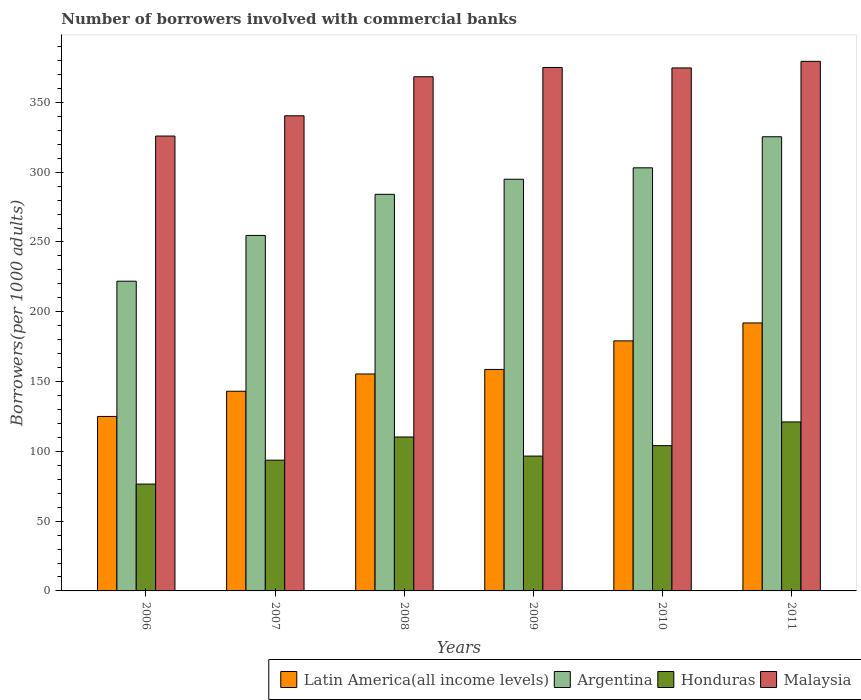How many different coloured bars are there?
Your response must be concise. 4. How many groups of bars are there?
Give a very brief answer. 6. Are the number of bars per tick equal to the number of legend labels?
Your answer should be very brief. Yes. How many bars are there on the 1st tick from the right?
Provide a succinct answer. 4. In how many cases, is the number of bars for a given year not equal to the number of legend labels?
Make the answer very short. 0. What is the number of borrowers involved with commercial banks in Malaysia in 2010?
Your answer should be compact. 374.71. Across all years, what is the maximum number of borrowers involved with commercial banks in Honduras?
Ensure brevity in your answer.  121.07. Across all years, what is the minimum number of borrowers involved with commercial banks in Argentina?
Give a very brief answer. 221.91. In which year was the number of borrowers involved with commercial banks in Latin America(all income levels) maximum?
Keep it short and to the point. 2011. What is the total number of borrowers involved with commercial banks in Honduras in the graph?
Ensure brevity in your answer.  602.3. What is the difference between the number of borrowers involved with commercial banks in Latin America(all income levels) in 2007 and that in 2009?
Make the answer very short. -15.62. What is the difference between the number of borrowers involved with commercial banks in Argentina in 2010 and the number of borrowers involved with commercial banks in Malaysia in 2009?
Provide a succinct answer. -71.88. What is the average number of borrowers involved with commercial banks in Argentina per year?
Ensure brevity in your answer.  280.71. In the year 2006, what is the difference between the number of borrowers involved with commercial banks in Argentina and number of borrowers involved with commercial banks in Latin America(all income levels)?
Your answer should be very brief. 96.91. What is the ratio of the number of borrowers involved with commercial banks in Malaysia in 2007 to that in 2010?
Keep it short and to the point. 0.91. What is the difference between the highest and the second highest number of borrowers involved with commercial banks in Argentina?
Your answer should be very brief. 22.25. What is the difference between the highest and the lowest number of borrowers involved with commercial banks in Honduras?
Your answer should be very brief. 44.52. What does the 4th bar from the left in 2011 represents?
Provide a succinct answer. Malaysia. What does the 2nd bar from the right in 2008 represents?
Provide a short and direct response. Honduras. How many bars are there?
Make the answer very short. 24. What is the difference between two consecutive major ticks on the Y-axis?
Your answer should be very brief. 50. Does the graph contain any zero values?
Your response must be concise. No. Does the graph contain grids?
Your answer should be very brief. No. Where does the legend appear in the graph?
Make the answer very short. Bottom right. How many legend labels are there?
Provide a succinct answer. 4. What is the title of the graph?
Provide a short and direct response. Number of borrowers involved with commercial banks. Does "Euro area" appear as one of the legend labels in the graph?
Give a very brief answer. No. What is the label or title of the Y-axis?
Offer a terse response. Borrowers(per 1000 adults). What is the Borrowers(per 1000 adults) in Latin America(all income levels) in 2006?
Your answer should be very brief. 125.01. What is the Borrowers(per 1000 adults) of Argentina in 2006?
Provide a short and direct response. 221.91. What is the Borrowers(per 1000 adults) of Honduras in 2006?
Your response must be concise. 76.56. What is the Borrowers(per 1000 adults) of Malaysia in 2006?
Offer a very short reply. 325.9. What is the Borrowers(per 1000 adults) in Latin America(all income levels) in 2007?
Keep it short and to the point. 143.06. What is the Borrowers(per 1000 adults) of Argentina in 2007?
Your answer should be compact. 254.69. What is the Borrowers(per 1000 adults) of Honduras in 2007?
Offer a very short reply. 93.68. What is the Borrowers(per 1000 adults) of Malaysia in 2007?
Make the answer very short. 340.42. What is the Borrowers(per 1000 adults) in Latin America(all income levels) in 2008?
Your response must be concise. 155.43. What is the Borrowers(per 1000 adults) of Argentina in 2008?
Provide a succinct answer. 284.14. What is the Borrowers(per 1000 adults) of Honduras in 2008?
Offer a terse response. 110.29. What is the Borrowers(per 1000 adults) of Malaysia in 2008?
Ensure brevity in your answer.  368.39. What is the Borrowers(per 1000 adults) in Latin America(all income levels) in 2009?
Offer a terse response. 158.68. What is the Borrowers(per 1000 adults) in Argentina in 2009?
Ensure brevity in your answer.  294.97. What is the Borrowers(per 1000 adults) in Honduras in 2009?
Offer a very short reply. 96.61. What is the Borrowers(per 1000 adults) of Malaysia in 2009?
Provide a short and direct response. 375.03. What is the Borrowers(per 1000 adults) in Latin America(all income levels) in 2010?
Make the answer very short. 179.15. What is the Borrowers(per 1000 adults) in Argentina in 2010?
Provide a succinct answer. 303.14. What is the Borrowers(per 1000 adults) of Honduras in 2010?
Offer a terse response. 104.09. What is the Borrowers(per 1000 adults) of Malaysia in 2010?
Offer a terse response. 374.71. What is the Borrowers(per 1000 adults) in Latin America(all income levels) in 2011?
Make the answer very short. 191.98. What is the Borrowers(per 1000 adults) in Argentina in 2011?
Your answer should be very brief. 325.39. What is the Borrowers(per 1000 adults) of Honduras in 2011?
Provide a succinct answer. 121.07. What is the Borrowers(per 1000 adults) in Malaysia in 2011?
Your answer should be compact. 379.42. Across all years, what is the maximum Borrowers(per 1000 adults) of Latin America(all income levels)?
Your answer should be compact. 191.98. Across all years, what is the maximum Borrowers(per 1000 adults) in Argentina?
Make the answer very short. 325.39. Across all years, what is the maximum Borrowers(per 1000 adults) in Honduras?
Your answer should be very brief. 121.07. Across all years, what is the maximum Borrowers(per 1000 adults) in Malaysia?
Provide a short and direct response. 379.42. Across all years, what is the minimum Borrowers(per 1000 adults) of Latin America(all income levels)?
Offer a very short reply. 125.01. Across all years, what is the minimum Borrowers(per 1000 adults) of Argentina?
Offer a terse response. 221.91. Across all years, what is the minimum Borrowers(per 1000 adults) in Honduras?
Give a very brief answer. 76.56. Across all years, what is the minimum Borrowers(per 1000 adults) in Malaysia?
Provide a short and direct response. 325.9. What is the total Borrowers(per 1000 adults) of Latin America(all income levels) in the graph?
Offer a very short reply. 953.32. What is the total Borrowers(per 1000 adults) of Argentina in the graph?
Give a very brief answer. 1684.25. What is the total Borrowers(per 1000 adults) in Honduras in the graph?
Provide a short and direct response. 602.3. What is the total Borrowers(per 1000 adults) in Malaysia in the graph?
Your answer should be very brief. 2163.87. What is the difference between the Borrowers(per 1000 adults) in Latin America(all income levels) in 2006 and that in 2007?
Keep it short and to the point. -18.05. What is the difference between the Borrowers(per 1000 adults) of Argentina in 2006 and that in 2007?
Offer a very short reply. -32.78. What is the difference between the Borrowers(per 1000 adults) in Honduras in 2006 and that in 2007?
Your answer should be very brief. -17.13. What is the difference between the Borrowers(per 1000 adults) in Malaysia in 2006 and that in 2007?
Keep it short and to the point. -14.51. What is the difference between the Borrowers(per 1000 adults) in Latin America(all income levels) in 2006 and that in 2008?
Your answer should be very brief. -30.42. What is the difference between the Borrowers(per 1000 adults) in Argentina in 2006 and that in 2008?
Make the answer very short. -62.22. What is the difference between the Borrowers(per 1000 adults) of Honduras in 2006 and that in 2008?
Provide a short and direct response. -33.74. What is the difference between the Borrowers(per 1000 adults) in Malaysia in 2006 and that in 2008?
Provide a succinct answer. -42.49. What is the difference between the Borrowers(per 1000 adults) in Latin America(all income levels) in 2006 and that in 2009?
Provide a succinct answer. -33.68. What is the difference between the Borrowers(per 1000 adults) of Argentina in 2006 and that in 2009?
Offer a very short reply. -73.06. What is the difference between the Borrowers(per 1000 adults) of Honduras in 2006 and that in 2009?
Offer a very short reply. -20.05. What is the difference between the Borrowers(per 1000 adults) of Malaysia in 2006 and that in 2009?
Keep it short and to the point. -49.12. What is the difference between the Borrowers(per 1000 adults) of Latin America(all income levels) in 2006 and that in 2010?
Give a very brief answer. -54.14. What is the difference between the Borrowers(per 1000 adults) in Argentina in 2006 and that in 2010?
Ensure brevity in your answer.  -81.23. What is the difference between the Borrowers(per 1000 adults) in Honduras in 2006 and that in 2010?
Ensure brevity in your answer.  -27.54. What is the difference between the Borrowers(per 1000 adults) in Malaysia in 2006 and that in 2010?
Ensure brevity in your answer.  -48.81. What is the difference between the Borrowers(per 1000 adults) in Latin America(all income levels) in 2006 and that in 2011?
Keep it short and to the point. -66.97. What is the difference between the Borrowers(per 1000 adults) of Argentina in 2006 and that in 2011?
Keep it short and to the point. -103.48. What is the difference between the Borrowers(per 1000 adults) in Honduras in 2006 and that in 2011?
Make the answer very short. -44.52. What is the difference between the Borrowers(per 1000 adults) of Malaysia in 2006 and that in 2011?
Keep it short and to the point. -53.51. What is the difference between the Borrowers(per 1000 adults) in Latin America(all income levels) in 2007 and that in 2008?
Provide a succinct answer. -12.37. What is the difference between the Borrowers(per 1000 adults) in Argentina in 2007 and that in 2008?
Your response must be concise. -29.45. What is the difference between the Borrowers(per 1000 adults) in Honduras in 2007 and that in 2008?
Give a very brief answer. -16.61. What is the difference between the Borrowers(per 1000 adults) of Malaysia in 2007 and that in 2008?
Keep it short and to the point. -27.98. What is the difference between the Borrowers(per 1000 adults) of Latin America(all income levels) in 2007 and that in 2009?
Your answer should be compact. -15.62. What is the difference between the Borrowers(per 1000 adults) of Argentina in 2007 and that in 2009?
Your answer should be very brief. -40.28. What is the difference between the Borrowers(per 1000 adults) of Honduras in 2007 and that in 2009?
Keep it short and to the point. -2.93. What is the difference between the Borrowers(per 1000 adults) of Malaysia in 2007 and that in 2009?
Your response must be concise. -34.61. What is the difference between the Borrowers(per 1000 adults) in Latin America(all income levels) in 2007 and that in 2010?
Your answer should be compact. -36.09. What is the difference between the Borrowers(per 1000 adults) of Argentina in 2007 and that in 2010?
Make the answer very short. -48.45. What is the difference between the Borrowers(per 1000 adults) in Honduras in 2007 and that in 2010?
Your response must be concise. -10.41. What is the difference between the Borrowers(per 1000 adults) in Malaysia in 2007 and that in 2010?
Your answer should be very brief. -34.3. What is the difference between the Borrowers(per 1000 adults) in Latin America(all income levels) in 2007 and that in 2011?
Give a very brief answer. -48.92. What is the difference between the Borrowers(per 1000 adults) of Argentina in 2007 and that in 2011?
Provide a short and direct response. -70.7. What is the difference between the Borrowers(per 1000 adults) in Honduras in 2007 and that in 2011?
Your answer should be compact. -27.39. What is the difference between the Borrowers(per 1000 adults) of Malaysia in 2007 and that in 2011?
Your answer should be very brief. -39. What is the difference between the Borrowers(per 1000 adults) of Latin America(all income levels) in 2008 and that in 2009?
Make the answer very short. -3.25. What is the difference between the Borrowers(per 1000 adults) in Argentina in 2008 and that in 2009?
Keep it short and to the point. -10.83. What is the difference between the Borrowers(per 1000 adults) in Honduras in 2008 and that in 2009?
Offer a very short reply. 13.68. What is the difference between the Borrowers(per 1000 adults) of Malaysia in 2008 and that in 2009?
Provide a succinct answer. -6.64. What is the difference between the Borrowers(per 1000 adults) in Latin America(all income levels) in 2008 and that in 2010?
Make the answer very short. -23.72. What is the difference between the Borrowers(per 1000 adults) in Argentina in 2008 and that in 2010?
Keep it short and to the point. -19.01. What is the difference between the Borrowers(per 1000 adults) of Honduras in 2008 and that in 2010?
Make the answer very short. 6.2. What is the difference between the Borrowers(per 1000 adults) of Malaysia in 2008 and that in 2010?
Offer a terse response. -6.32. What is the difference between the Borrowers(per 1000 adults) in Latin America(all income levels) in 2008 and that in 2011?
Your answer should be compact. -36.55. What is the difference between the Borrowers(per 1000 adults) in Argentina in 2008 and that in 2011?
Provide a short and direct response. -41.25. What is the difference between the Borrowers(per 1000 adults) in Honduras in 2008 and that in 2011?
Keep it short and to the point. -10.78. What is the difference between the Borrowers(per 1000 adults) in Malaysia in 2008 and that in 2011?
Make the answer very short. -11.03. What is the difference between the Borrowers(per 1000 adults) of Latin America(all income levels) in 2009 and that in 2010?
Keep it short and to the point. -20.47. What is the difference between the Borrowers(per 1000 adults) in Argentina in 2009 and that in 2010?
Make the answer very short. -8.17. What is the difference between the Borrowers(per 1000 adults) in Honduras in 2009 and that in 2010?
Offer a terse response. -7.48. What is the difference between the Borrowers(per 1000 adults) of Malaysia in 2009 and that in 2010?
Make the answer very short. 0.32. What is the difference between the Borrowers(per 1000 adults) of Latin America(all income levels) in 2009 and that in 2011?
Your answer should be compact. -33.3. What is the difference between the Borrowers(per 1000 adults) in Argentina in 2009 and that in 2011?
Make the answer very short. -30.42. What is the difference between the Borrowers(per 1000 adults) of Honduras in 2009 and that in 2011?
Your answer should be very brief. -24.46. What is the difference between the Borrowers(per 1000 adults) of Malaysia in 2009 and that in 2011?
Give a very brief answer. -4.39. What is the difference between the Borrowers(per 1000 adults) of Latin America(all income levels) in 2010 and that in 2011?
Your answer should be very brief. -12.83. What is the difference between the Borrowers(per 1000 adults) of Argentina in 2010 and that in 2011?
Your answer should be compact. -22.25. What is the difference between the Borrowers(per 1000 adults) in Honduras in 2010 and that in 2011?
Provide a short and direct response. -16.98. What is the difference between the Borrowers(per 1000 adults) in Malaysia in 2010 and that in 2011?
Offer a terse response. -4.71. What is the difference between the Borrowers(per 1000 adults) in Latin America(all income levels) in 2006 and the Borrowers(per 1000 adults) in Argentina in 2007?
Ensure brevity in your answer.  -129.68. What is the difference between the Borrowers(per 1000 adults) of Latin America(all income levels) in 2006 and the Borrowers(per 1000 adults) of Honduras in 2007?
Your answer should be compact. 31.33. What is the difference between the Borrowers(per 1000 adults) in Latin America(all income levels) in 2006 and the Borrowers(per 1000 adults) in Malaysia in 2007?
Ensure brevity in your answer.  -215.41. What is the difference between the Borrowers(per 1000 adults) of Argentina in 2006 and the Borrowers(per 1000 adults) of Honduras in 2007?
Give a very brief answer. 128.23. What is the difference between the Borrowers(per 1000 adults) of Argentina in 2006 and the Borrowers(per 1000 adults) of Malaysia in 2007?
Keep it short and to the point. -118.5. What is the difference between the Borrowers(per 1000 adults) in Honduras in 2006 and the Borrowers(per 1000 adults) in Malaysia in 2007?
Provide a short and direct response. -263.86. What is the difference between the Borrowers(per 1000 adults) in Latin America(all income levels) in 2006 and the Borrowers(per 1000 adults) in Argentina in 2008?
Keep it short and to the point. -159.13. What is the difference between the Borrowers(per 1000 adults) in Latin America(all income levels) in 2006 and the Borrowers(per 1000 adults) in Honduras in 2008?
Make the answer very short. 14.72. What is the difference between the Borrowers(per 1000 adults) in Latin America(all income levels) in 2006 and the Borrowers(per 1000 adults) in Malaysia in 2008?
Keep it short and to the point. -243.38. What is the difference between the Borrowers(per 1000 adults) of Argentina in 2006 and the Borrowers(per 1000 adults) of Honduras in 2008?
Your answer should be compact. 111.62. What is the difference between the Borrowers(per 1000 adults) in Argentina in 2006 and the Borrowers(per 1000 adults) in Malaysia in 2008?
Offer a terse response. -146.48. What is the difference between the Borrowers(per 1000 adults) of Honduras in 2006 and the Borrowers(per 1000 adults) of Malaysia in 2008?
Ensure brevity in your answer.  -291.84. What is the difference between the Borrowers(per 1000 adults) in Latin America(all income levels) in 2006 and the Borrowers(per 1000 adults) in Argentina in 2009?
Offer a terse response. -169.96. What is the difference between the Borrowers(per 1000 adults) of Latin America(all income levels) in 2006 and the Borrowers(per 1000 adults) of Honduras in 2009?
Keep it short and to the point. 28.4. What is the difference between the Borrowers(per 1000 adults) in Latin America(all income levels) in 2006 and the Borrowers(per 1000 adults) in Malaysia in 2009?
Your answer should be compact. -250.02. What is the difference between the Borrowers(per 1000 adults) in Argentina in 2006 and the Borrowers(per 1000 adults) in Honduras in 2009?
Your answer should be very brief. 125.3. What is the difference between the Borrowers(per 1000 adults) in Argentina in 2006 and the Borrowers(per 1000 adults) in Malaysia in 2009?
Your answer should be very brief. -153.11. What is the difference between the Borrowers(per 1000 adults) in Honduras in 2006 and the Borrowers(per 1000 adults) in Malaysia in 2009?
Provide a succinct answer. -298.47. What is the difference between the Borrowers(per 1000 adults) in Latin America(all income levels) in 2006 and the Borrowers(per 1000 adults) in Argentina in 2010?
Provide a short and direct response. -178.14. What is the difference between the Borrowers(per 1000 adults) in Latin America(all income levels) in 2006 and the Borrowers(per 1000 adults) in Honduras in 2010?
Make the answer very short. 20.92. What is the difference between the Borrowers(per 1000 adults) of Latin America(all income levels) in 2006 and the Borrowers(per 1000 adults) of Malaysia in 2010?
Keep it short and to the point. -249.7. What is the difference between the Borrowers(per 1000 adults) of Argentina in 2006 and the Borrowers(per 1000 adults) of Honduras in 2010?
Your response must be concise. 117.82. What is the difference between the Borrowers(per 1000 adults) of Argentina in 2006 and the Borrowers(per 1000 adults) of Malaysia in 2010?
Your response must be concise. -152.8. What is the difference between the Borrowers(per 1000 adults) in Honduras in 2006 and the Borrowers(per 1000 adults) in Malaysia in 2010?
Provide a short and direct response. -298.16. What is the difference between the Borrowers(per 1000 adults) in Latin America(all income levels) in 2006 and the Borrowers(per 1000 adults) in Argentina in 2011?
Offer a very short reply. -200.38. What is the difference between the Borrowers(per 1000 adults) in Latin America(all income levels) in 2006 and the Borrowers(per 1000 adults) in Honduras in 2011?
Your response must be concise. 3.94. What is the difference between the Borrowers(per 1000 adults) in Latin America(all income levels) in 2006 and the Borrowers(per 1000 adults) in Malaysia in 2011?
Your answer should be compact. -254.41. What is the difference between the Borrowers(per 1000 adults) of Argentina in 2006 and the Borrowers(per 1000 adults) of Honduras in 2011?
Your answer should be compact. 100.84. What is the difference between the Borrowers(per 1000 adults) in Argentina in 2006 and the Borrowers(per 1000 adults) in Malaysia in 2011?
Give a very brief answer. -157.5. What is the difference between the Borrowers(per 1000 adults) of Honduras in 2006 and the Borrowers(per 1000 adults) of Malaysia in 2011?
Offer a very short reply. -302.86. What is the difference between the Borrowers(per 1000 adults) of Latin America(all income levels) in 2007 and the Borrowers(per 1000 adults) of Argentina in 2008?
Offer a terse response. -141.08. What is the difference between the Borrowers(per 1000 adults) of Latin America(all income levels) in 2007 and the Borrowers(per 1000 adults) of Honduras in 2008?
Your response must be concise. 32.77. What is the difference between the Borrowers(per 1000 adults) of Latin America(all income levels) in 2007 and the Borrowers(per 1000 adults) of Malaysia in 2008?
Give a very brief answer. -225.33. What is the difference between the Borrowers(per 1000 adults) of Argentina in 2007 and the Borrowers(per 1000 adults) of Honduras in 2008?
Your response must be concise. 144.4. What is the difference between the Borrowers(per 1000 adults) in Argentina in 2007 and the Borrowers(per 1000 adults) in Malaysia in 2008?
Your answer should be compact. -113.7. What is the difference between the Borrowers(per 1000 adults) in Honduras in 2007 and the Borrowers(per 1000 adults) in Malaysia in 2008?
Offer a terse response. -274.71. What is the difference between the Borrowers(per 1000 adults) of Latin America(all income levels) in 2007 and the Borrowers(per 1000 adults) of Argentina in 2009?
Offer a very short reply. -151.91. What is the difference between the Borrowers(per 1000 adults) of Latin America(all income levels) in 2007 and the Borrowers(per 1000 adults) of Honduras in 2009?
Your response must be concise. 46.45. What is the difference between the Borrowers(per 1000 adults) in Latin America(all income levels) in 2007 and the Borrowers(per 1000 adults) in Malaysia in 2009?
Offer a terse response. -231.97. What is the difference between the Borrowers(per 1000 adults) of Argentina in 2007 and the Borrowers(per 1000 adults) of Honduras in 2009?
Your response must be concise. 158.08. What is the difference between the Borrowers(per 1000 adults) of Argentina in 2007 and the Borrowers(per 1000 adults) of Malaysia in 2009?
Give a very brief answer. -120.34. What is the difference between the Borrowers(per 1000 adults) in Honduras in 2007 and the Borrowers(per 1000 adults) in Malaysia in 2009?
Keep it short and to the point. -281.35. What is the difference between the Borrowers(per 1000 adults) of Latin America(all income levels) in 2007 and the Borrowers(per 1000 adults) of Argentina in 2010?
Offer a terse response. -160.08. What is the difference between the Borrowers(per 1000 adults) in Latin America(all income levels) in 2007 and the Borrowers(per 1000 adults) in Honduras in 2010?
Provide a succinct answer. 38.97. What is the difference between the Borrowers(per 1000 adults) in Latin America(all income levels) in 2007 and the Borrowers(per 1000 adults) in Malaysia in 2010?
Offer a very short reply. -231.65. What is the difference between the Borrowers(per 1000 adults) in Argentina in 2007 and the Borrowers(per 1000 adults) in Honduras in 2010?
Provide a short and direct response. 150.6. What is the difference between the Borrowers(per 1000 adults) of Argentina in 2007 and the Borrowers(per 1000 adults) of Malaysia in 2010?
Provide a short and direct response. -120.02. What is the difference between the Borrowers(per 1000 adults) in Honduras in 2007 and the Borrowers(per 1000 adults) in Malaysia in 2010?
Offer a very short reply. -281.03. What is the difference between the Borrowers(per 1000 adults) of Latin America(all income levels) in 2007 and the Borrowers(per 1000 adults) of Argentina in 2011?
Your response must be concise. -182.33. What is the difference between the Borrowers(per 1000 adults) of Latin America(all income levels) in 2007 and the Borrowers(per 1000 adults) of Honduras in 2011?
Your answer should be compact. 21.99. What is the difference between the Borrowers(per 1000 adults) of Latin America(all income levels) in 2007 and the Borrowers(per 1000 adults) of Malaysia in 2011?
Give a very brief answer. -236.36. What is the difference between the Borrowers(per 1000 adults) of Argentina in 2007 and the Borrowers(per 1000 adults) of Honduras in 2011?
Keep it short and to the point. 133.62. What is the difference between the Borrowers(per 1000 adults) in Argentina in 2007 and the Borrowers(per 1000 adults) in Malaysia in 2011?
Offer a very short reply. -124.73. What is the difference between the Borrowers(per 1000 adults) in Honduras in 2007 and the Borrowers(per 1000 adults) in Malaysia in 2011?
Your answer should be very brief. -285.74. What is the difference between the Borrowers(per 1000 adults) in Latin America(all income levels) in 2008 and the Borrowers(per 1000 adults) in Argentina in 2009?
Make the answer very short. -139.54. What is the difference between the Borrowers(per 1000 adults) in Latin America(all income levels) in 2008 and the Borrowers(per 1000 adults) in Honduras in 2009?
Offer a very short reply. 58.82. What is the difference between the Borrowers(per 1000 adults) in Latin America(all income levels) in 2008 and the Borrowers(per 1000 adults) in Malaysia in 2009?
Your answer should be compact. -219.6. What is the difference between the Borrowers(per 1000 adults) in Argentina in 2008 and the Borrowers(per 1000 adults) in Honduras in 2009?
Keep it short and to the point. 187.53. What is the difference between the Borrowers(per 1000 adults) in Argentina in 2008 and the Borrowers(per 1000 adults) in Malaysia in 2009?
Provide a succinct answer. -90.89. What is the difference between the Borrowers(per 1000 adults) of Honduras in 2008 and the Borrowers(per 1000 adults) of Malaysia in 2009?
Ensure brevity in your answer.  -264.74. What is the difference between the Borrowers(per 1000 adults) of Latin America(all income levels) in 2008 and the Borrowers(per 1000 adults) of Argentina in 2010?
Provide a succinct answer. -147.71. What is the difference between the Borrowers(per 1000 adults) in Latin America(all income levels) in 2008 and the Borrowers(per 1000 adults) in Honduras in 2010?
Provide a short and direct response. 51.34. What is the difference between the Borrowers(per 1000 adults) of Latin America(all income levels) in 2008 and the Borrowers(per 1000 adults) of Malaysia in 2010?
Ensure brevity in your answer.  -219.28. What is the difference between the Borrowers(per 1000 adults) of Argentina in 2008 and the Borrowers(per 1000 adults) of Honduras in 2010?
Keep it short and to the point. 180.04. What is the difference between the Borrowers(per 1000 adults) in Argentina in 2008 and the Borrowers(per 1000 adults) in Malaysia in 2010?
Your answer should be very brief. -90.58. What is the difference between the Borrowers(per 1000 adults) in Honduras in 2008 and the Borrowers(per 1000 adults) in Malaysia in 2010?
Keep it short and to the point. -264.42. What is the difference between the Borrowers(per 1000 adults) in Latin America(all income levels) in 2008 and the Borrowers(per 1000 adults) in Argentina in 2011?
Ensure brevity in your answer.  -169.96. What is the difference between the Borrowers(per 1000 adults) in Latin America(all income levels) in 2008 and the Borrowers(per 1000 adults) in Honduras in 2011?
Make the answer very short. 34.36. What is the difference between the Borrowers(per 1000 adults) in Latin America(all income levels) in 2008 and the Borrowers(per 1000 adults) in Malaysia in 2011?
Provide a succinct answer. -223.99. What is the difference between the Borrowers(per 1000 adults) of Argentina in 2008 and the Borrowers(per 1000 adults) of Honduras in 2011?
Ensure brevity in your answer.  163.06. What is the difference between the Borrowers(per 1000 adults) in Argentina in 2008 and the Borrowers(per 1000 adults) in Malaysia in 2011?
Your answer should be very brief. -95.28. What is the difference between the Borrowers(per 1000 adults) in Honduras in 2008 and the Borrowers(per 1000 adults) in Malaysia in 2011?
Keep it short and to the point. -269.13. What is the difference between the Borrowers(per 1000 adults) of Latin America(all income levels) in 2009 and the Borrowers(per 1000 adults) of Argentina in 2010?
Give a very brief answer. -144.46. What is the difference between the Borrowers(per 1000 adults) in Latin America(all income levels) in 2009 and the Borrowers(per 1000 adults) in Honduras in 2010?
Your response must be concise. 54.59. What is the difference between the Borrowers(per 1000 adults) of Latin America(all income levels) in 2009 and the Borrowers(per 1000 adults) of Malaysia in 2010?
Provide a short and direct response. -216.03. What is the difference between the Borrowers(per 1000 adults) of Argentina in 2009 and the Borrowers(per 1000 adults) of Honduras in 2010?
Give a very brief answer. 190.88. What is the difference between the Borrowers(per 1000 adults) of Argentina in 2009 and the Borrowers(per 1000 adults) of Malaysia in 2010?
Your answer should be compact. -79.74. What is the difference between the Borrowers(per 1000 adults) of Honduras in 2009 and the Borrowers(per 1000 adults) of Malaysia in 2010?
Your response must be concise. -278.1. What is the difference between the Borrowers(per 1000 adults) in Latin America(all income levels) in 2009 and the Borrowers(per 1000 adults) in Argentina in 2011?
Your response must be concise. -166.71. What is the difference between the Borrowers(per 1000 adults) in Latin America(all income levels) in 2009 and the Borrowers(per 1000 adults) in Honduras in 2011?
Ensure brevity in your answer.  37.61. What is the difference between the Borrowers(per 1000 adults) in Latin America(all income levels) in 2009 and the Borrowers(per 1000 adults) in Malaysia in 2011?
Offer a very short reply. -220.73. What is the difference between the Borrowers(per 1000 adults) of Argentina in 2009 and the Borrowers(per 1000 adults) of Honduras in 2011?
Offer a very short reply. 173.9. What is the difference between the Borrowers(per 1000 adults) of Argentina in 2009 and the Borrowers(per 1000 adults) of Malaysia in 2011?
Your answer should be very brief. -84.45. What is the difference between the Borrowers(per 1000 adults) of Honduras in 2009 and the Borrowers(per 1000 adults) of Malaysia in 2011?
Provide a short and direct response. -282.81. What is the difference between the Borrowers(per 1000 adults) of Latin America(all income levels) in 2010 and the Borrowers(per 1000 adults) of Argentina in 2011?
Make the answer very short. -146.24. What is the difference between the Borrowers(per 1000 adults) in Latin America(all income levels) in 2010 and the Borrowers(per 1000 adults) in Honduras in 2011?
Ensure brevity in your answer.  58.08. What is the difference between the Borrowers(per 1000 adults) of Latin America(all income levels) in 2010 and the Borrowers(per 1000 adults) of Malaysia in 2011?
Ensure brevity in your answer.  -200.27. What is the difference between the Borrowers(per 1000 adults) in Argentina in 2010 and the Borrowers(per 1000 adults) in Honduras in 2011?
Keep it short and to the point. 182.07. What is the difference between the Borrowers(per 1000 adults) in Argentina in 2010 and the Borrowers(per 1000 adults) in Malaysia in 2011?
Your answer should be very brief. -76.27. What is the difference between the Borrowers(per 1000 adults) of Honduras in 2010 and the Borrowers(per 1000 adults) of Malaysia in 2011?
Your response must be concise. -275.33. What is the average Borrowers(per 1000 adults) in Latin America(all income levels) per year?
Your answer should be very brief. 158.89. What is the average Borrowers(per 1000 adults) of Argentina per year?
Offer a terse response. 280.71. What is the average Borrowers(per 1000 adults) in Honduras per year?
Make the answer very short. 100.38. What is the average Borrowers(per 1000 adults) in Malaysia per year?
Keep it short and to the point. 360.65. In the year 2006, what is the difference between the Borrowers(per 1000 adults) in Latin America(all income levels) and Borrowers(per 1000 adults) in Argentina?
Your response must be concise. -96.91. In the year 2006, what is the difference between the Borrowers(per 1000 adults) in Latin America(all income levels) and Borrowers(per 1000 adults) in Honduras?
Your answer should be very brief. 48.45. In the year 2006, what is the difference between the Borrowers(per 1000 adults) of Latin America(all income levels) and Borrowers(per 1000 adults) of Malaysia?
Your answer should be very brief. -200.9. In the year 2006, what is the difference between the Borrowers(per 1000 adults) of Argentina and Borrowers(per 1000 adults) of Honduras?
Keep it short and to the point. 145.36. In the year 2006, what is the difference between the Borrowers(per 1000 adults) in Argentina and Borrowers(per 1000 adults) in Malaysia?
Keep it short and to the point. -103.99. In the year 2006, what is the difference between the Borrowers(per 1000 adults) of Honduras and Borrowers(per 1000 adults) of Malaysia?
Give a very brief answer. -249.35. In the year 2007, what is the difference between the Borrowers(per 1000 adults) in Latin America(all income levels) and Borrowers(per 1000 adults) in Argentina?
Provide a succinct answer. -111.63. In the year 2007, what is the difference between the Borrowers(per 1000 adults) in Latin America(all income levels) and Borrowers(per 1000 adults) in Honduras?
Your answer should be very brief. 49.38. In the year 2007, what is the difference between the Borrowers(per 1000 adults) in Latin America(all income levels) and Borrowers(per 1000 adults) in Malaysia?
Provide a short and direct response. -197.36. In the year 2007, what is the difference between the Borrowers(per 1000 adults) in Argentina and Borrowers(per 1000 adults) in Honduras?
Ensure brevity in your answer.  161.01. In the year 2007, what is the difference between the Borrowers(per 1000 adults) of Argentina and Borrowers(per 1000 adults) of Malaysia?
Make the answer very short. -85.72. In the year 2007, what is the difference between the Borrowers(per 1000 adults) in Honduras and Borrowers(per 1000 adults) in Malaysia?
Make the answer very short. -246.73. In the year 2008, what is the difference between the Borrowers(per 1000 adults) of Latin America(all income levels) and Borrowers(per 1000 adults) of Argentina?
Make the answer very short. -128.7. In the year 2008, what is the difference between the Borrowers(per 1000 adults) of Latin America(all income levels) and Borrowers(per 1000 adults) of Honduras?
Give a very brief answer. 45.14. In the year 2008, what is the difference between the Borrowers(per 1000 adults) of Latin America(all income levels) and Borrowers(per 1000 adults) of Malaysia?
Offer a very short reply. -212.96. In the year 2008, what is the difference between the Borrowers(per 1000 adults) of Argentina and Borrowers(per 1000 adults) of Honduras?
Give a very brief answer. 173.85. In the year 2008, what is the difference between the Borrowers(per 1000 adults) in Argentina and Borrowers(per 1000 adults) in Malaysia?
Keep it short and to the point. -84.25. In the year 2008, what is the difference between the Borrowers(per 1000 adults) of Honduras and Borrowers(per 1000 adults) of Malaysia?
Provide a succinct answer. -258.1. In the year 2009, what is the difference between the Borrowers(per 1000 adults) in Latin America(all income levels) and Borrowers(per 1000 adults) in Argentina?
Make the answer very short. -136.29. In the year 2009, what is the difference between the Borrowers(per 1000 adults) of Latin America(all income levels) and Borrowers(per 1000 adults) of Honduras?
Offer a very short reply. 62.07. In the year 2009, what is the difference between the Borrowers(per 1000 adults) of Latin America(all income levels) and Borrowers(per 1000 adults) of Malaysia?
Make the answer very short. -216.34. In the year 2009, what is the difference between the Borrowers(per 1000 adults) in Argentina and Borrowers(per 1000 adults) in Honduras?
Your answer should be compact. 198.36. In the year 2009, what is the difference between the Borrowers(per 1000 adults) in Argentina and Borrowers(per 1000 adults) in Malaysia?
Ensure brevity in your answer.  -80.06. In the year 2009, what is the difference between the Borrowers(per 1000 adults) in Honduras and Borrowers(per 1000 adults) in Malaysia?
Your answer should be compact. -278.42. In the year 2010, what is the difference between the Borrowers(per 1000 adults) of Latin America(all income levels) and Borrowers(per 1000 adults) of Argentina?
Offer a terse response. -123.99. In the year 2010, what is the difference between the Borrowers(per 1000 adults) of Latin America(all income levels) and Borrowers(per 1000 adults) of Honduras?
Keep it short and to the point. 75.06. In the year 2010, what is the difference between the Borrowers(per 1000 adults) in Latin America(all income levels) and Borrowers(per 1000 adults) in Malaysia?
Provide a succinct answer. -195.56. In the year 2010, what is the difference between the Borrowers(per 1000 adults) in Argentina and Borrowers(per 1000 adults) in Honduras?
Provide a succinct answer. 199.05. In the year 2010, what is the difference between the Borrowers(per 1000 adults) of Argentina and Borrowers(per 1000 adults) of Malaysia?
Your answer should be very brief. -71.57. In the year 2010, what is the difference between the Borrowers(per 1000 adults) in Honduras and Borrowers(per 1000 adults) in Malaysia?
Offer a very short reply. -270.62. In the year 2011, what is the difference between the Borrowers(per 1000 adults) in Latin America(all income levels) and Borrowers(per 1000 adults) in Argentina?
Ensure brevity in your answer.  -133.41. In the year 2011, what is the difference between the Borrowers(per 1000 adults) of Latin America(all income levels) and Borrowers(per 1000 adults) of Honduras?
Offer a terse response. 70.91. In the year 2011, what is the difference between the Borrowers(per 1000 adults) of Latin America(all income levels) and Borrowers(per 1000 adults) of Malaysia?
Make the answer very short. -187.44. In the year 2011, what is the difference between the Borrowers(per 1000 adults) in Argentina and Borrowers(per 1000 adults) in Honduras?
Provide a short and direct response. 204.32. In the year 2011, what is the difference between the Borrowers(per 1000 adults) of Argentina and Borrowers(per 1000 adults) of Malaysia?
Provide a short and direct response. -54.03. In the year 2011, what is the difference between the Borrowers(per 1000 adults) of Honduras and Borrowers(per 1000 adults) of Malaysia?
Your response must be concise. -258.35. What is the ratio of the Borrowers(per 1000 adults) of Latin America(all income levels) in 2006 to that in 2007?
Your answer should be compact. 0.87. What is the ratio of the Borrowers(per 1000 adults) in Argentina in 2006 to that in 2007?
Offer a terse response. 0.87. What is the ratio of the Borrowers(per 1000 adults) of Honduras in 2006 to that in 2007?
Your answer should be compact. 0.82. What is the ratio of the Borrowers(per 1000 adults) of Malaysia in 2006 to that in 2007?
Make the answer very short. 0.96. What is the ratio of the Borrowers(per 1000 adults) in Latin America(all income levels) in 2006 to that in 2008?
Ensure brevity in your answer.  0.8. What is the ratio of the Borrowers(per 1000 adults) in Argentina in 2006 to that in 2008?
Keep it short and to the point. 0.78. What is the ratio of the Borrowers(per 1000 adults) in Honduras in 2006 to that in 2008?
Your response must be concise. 0.69. What is the ratio of the Borrowers(per 1000 adults) of Malaysia in 2006 to that in 2008?
Your answer should be very brief. 0.88. What is the ratio of the Borrowers(per 1000 adults) in Latin America(all income levels) in 2006 to that in 2009?
Give a very brief answer. 0.79. What is the ratio of the Borrowers(per 1000 adults) in Argentina in 2006 to that in 2009?
Provide a short and direct response. 0.75. What is the ratio of the Borrowers(per 1000 adults) in Honduras in 2006 to that in 2009?
Give a very brief answer. 0.79. What is the ratio of the Borrowers(per 1000 adults) of Malaysia in 2006 to that in 2009?
Your response must be concise. 0.87. What is the ratio of the Borrowers(per 1000 adults) in Latin America(all income levels) in 2006 to that in 2010?
Your response must be concise. 0.7. What is the ratio of the Borrowers(per 1000 adults) of Argentina in 2006 to that in 2010?
Provide a short and direct response. 0.73. What is the ratio of the Borrowers(per 1000 adults) in Honduras in 2006 to that in 2010?
Offer a terse response. 0.74. What is the ratio of the Borrowers(per 1000 adults) of Malaysia in 2006 to that in 2010?
Keep it short and to the point. 0.87. What is the ratio of the Borrowers(per 1000 adults) in Latin America(all income levels) in 2006 to that in 2011?
Your answer should be compact. 0.65. What is the ratio of the Borrowers(per 1000 adults) of Argentina in 2006 to that in 2011?
Offer a terse response. 0.68. What is the ratio of the Borrowers(per 1000 adults) of Honduras in 2006 to that in 2011?
Give a very brief answer. 0.63. What is the ratio of the Borrowers(per 1000 adults) of Malaysia in 2006 to that in 2011?
Provide a short and direct response. 0.86. What is the ratio of the Borrowers(per 1000 adults) of Latin America(all income levels) in 2007 to that in 2008?
Keep it short and to the point. 0.92. What is the ratio of the Borrowers(per 1000 adults) of Argentina in 2007 to that in 2008?
Your answer should be compact. 0.9. What is the ratio of the Borrowers(per 1000 adults) of Honduras in 2007 to that in 2008?
Offer a very short reply. 0.85. What is the ratio of the Borrowers(per 1000 adults) in Malaysia in 2007 to that in 2008?
Keep it short and to the point. 0.92. What is the ratio of the Borrowers(per 1000 adults) in Latin America(all income levels) in 2007 to that in 2009?
Give a very brief answer. 0.9. What is the ratio of the Borrowers(per 1000 adults) in Argentina in 2007 to that in 2009?
Give a very brief answer. 0.86. What is the ratio of the Borrowers(per 1000 adults) of Honduras in 2007 to that in 2009?
Give a very brief answer. 0.97. What is the ratio of the Borrowers(per 1000 adults) of Malaysia in 2007 to that in 2009?
Your response must be concise. 0.91. What is the ratio of the Borrowers(per 1000 adults) in Latin America(all income levels) in 2007 to that in 2010?
Your response must be concise. 0.8. What is the ratio of the Borrowers(per 1000 adults) of Argentina in 2007 to that in 2010?
Offer a terse response. 0.84. What is the ratio of the Borrowers(per 1000 adults) in Malaysia in 2007 to that in 2010?
Your response must be concise. 0.91. What is the ratio of the Borrowers(per 1000 adults) of Latin America(all income levels) in 2007 to that in 2011?
Offer a very short reply. 0.75. What is the ratio of the Borrowers(per 1000 adults) of Argentina in 2007 to that in 2011?
Make the answer very short. 0.78. What is the ratio of the Borrowers(per 1000 adults) of Honduras in 2007 to that in 2011?
Make the answer very short. 0.77. What is the ratio of the Borrowers(per 1000 adults) in Malaysia in 2007 to that in 2011?
Offer a terse response. 0.9. What is the ratio of the Borrowers(per 1000 adults) of Latin America(all income levels) in 2008 to that in 2009?
Make the answer very short. 0.98. What is the ratio of the Borrowers(per 1000 adults) of Argentina in 2008 to that in 2009?
Offer a terse response. 0.96. What is the ratio of the Borrowers(per 1000 adults) of Honduras in 2008 to that in 2009?
Keep it short and to the point. 1.14. What is the ratio of the Borrowers(per 1000 adults) in Malaysia in 2008 to that in 2009?
Ensure brevity in your answer.  0.98. What is the ratio of the Borrowers(per 1000 adults) in Latin America(all income levels) in 2008 to that in 2010?
Provide a succinct answer. 0.87. What is the ratio of the Borrowers(per 1000 adults) in Argentina in 2008 to that in 2010?
Your response must be concise. 0.94. What is the ratio of the Borrowers(per 1000 adults) in Honduras in 2008 to that in 2010?
Your response must be concise. 1.06. What is the ratio of the Borrowers(per 1000 adults) of Malaysia in 2008 to that in 2010?
Your answer should be very brief. 0.98. What is the ratio of the Borrowers(per 1000 adults) in Latin America(all income levels) in 2008 to that in 2011?
Your answer should be very brief. 0.81. What is the ratio of the Borrowers(per 1000 adults) in Argentina in 2008 to that in 2011?
Provide a short and direct response. 0.87. What is the ratio of the Borrowers(per 1000 adults) of Honduras in 2008 to that in 2011?
Your answer should be very brief. 0.91. What is the ratio of the Borrowers(per 1000 adults) in Malaysia in 2008 to that in 2011?
Your answer should be very brief. 0.97. What is the ratio of the Borrowers(per 1000 adults) of Latin America(all income levels) in 2009 to that in 2010?
Give a very brief answer. 0.89. What is the ratio of the Borrowers(per 1000 adults) of Argentina in 2009 to that in 2010?
Offer a very short reply. 0.97. What is the ratio of the Borrowers(per 1000 adults) of Honduras in 2009 to that in 2010?
Give a very brief answer. 0.93. What is the ratio of the Borrowers(per 1000 adults) in Malaysia in 2009 to that in 2010?
Provide a short and direct response. 1. What is the ratio of the Borrowers(per 1000 adults) of Latin America(all income levels) in 2009 to that in 2011?
Your response must be concise. 0.83. What is the ratio of the Borrowers(per 1000 adults) of Argentina in 2009 to that in 2011?
Offer a very short reply. 0.91. What is the ratio of the Borrowers(per 1000 adults) in Honduras in 2009 to that in 2011?
Keep it short and to the point. 0.8. What is the ratio of the Borrowers(per 1000 adults) of Malaysia in 2009 to that in 2011?
Your answer should be compact. 0.99. What is the ratio of the Borrowers(per 1000 adults) in Latin America(all income levels) in 2010 to that in 2011?
Your answer should be compact. 0.93. What is the ratio of the Borrowers(per 1000 adults) of Argentina in 2010 to that in 2011?
Give a very brief answer. 0.93. What is the ratio of the Borrowers(per 1000 adults) in Honduras in 2010 to that in 2011?
Your response must be concise. 0.86. What is the ratio of the Borrowers(per 1000 adults) in Malaysia in 2010 to that in 2011?
Your answer should be compact. 0.99. What is the difference between the highest and the second highest Borrowers(per 1000 adults) of Latin America(all income levels)?
Your response must be concise. 12.83. What is the difference between the highest and the second highest Borrowers(per 1000 adults) of Argentina?
Provide a succinct answer. 22.25. What is the difference between the highest and the second highest Borrowers(per 1000 adults) of Honduras?
Offer a very short reply. 10.78. What is the difference between the highest and the second highest Borrowers(per 1000 adults) of Malaysia?
Keep it short and to the point. 4.39. What is the difference between the highest and the lowest Borrowers(per 1000 adults) of Latin America(all income levels)?
Your answer should be very brief. 66.97. What is the difference between the highest and the lowest Borrowers(per 1000 adults) in Argentina?
Your answer should be very brief. 103.48. What is the difference between the highest and the lowest Borrowers(per 1000 adults) of Honduras?
Offer a very short reply. 44.52. What is the difference between the highest and the lowest Borrowers(per 1000 adults) in Malaysia?
Offer a terse response. 53.51. 